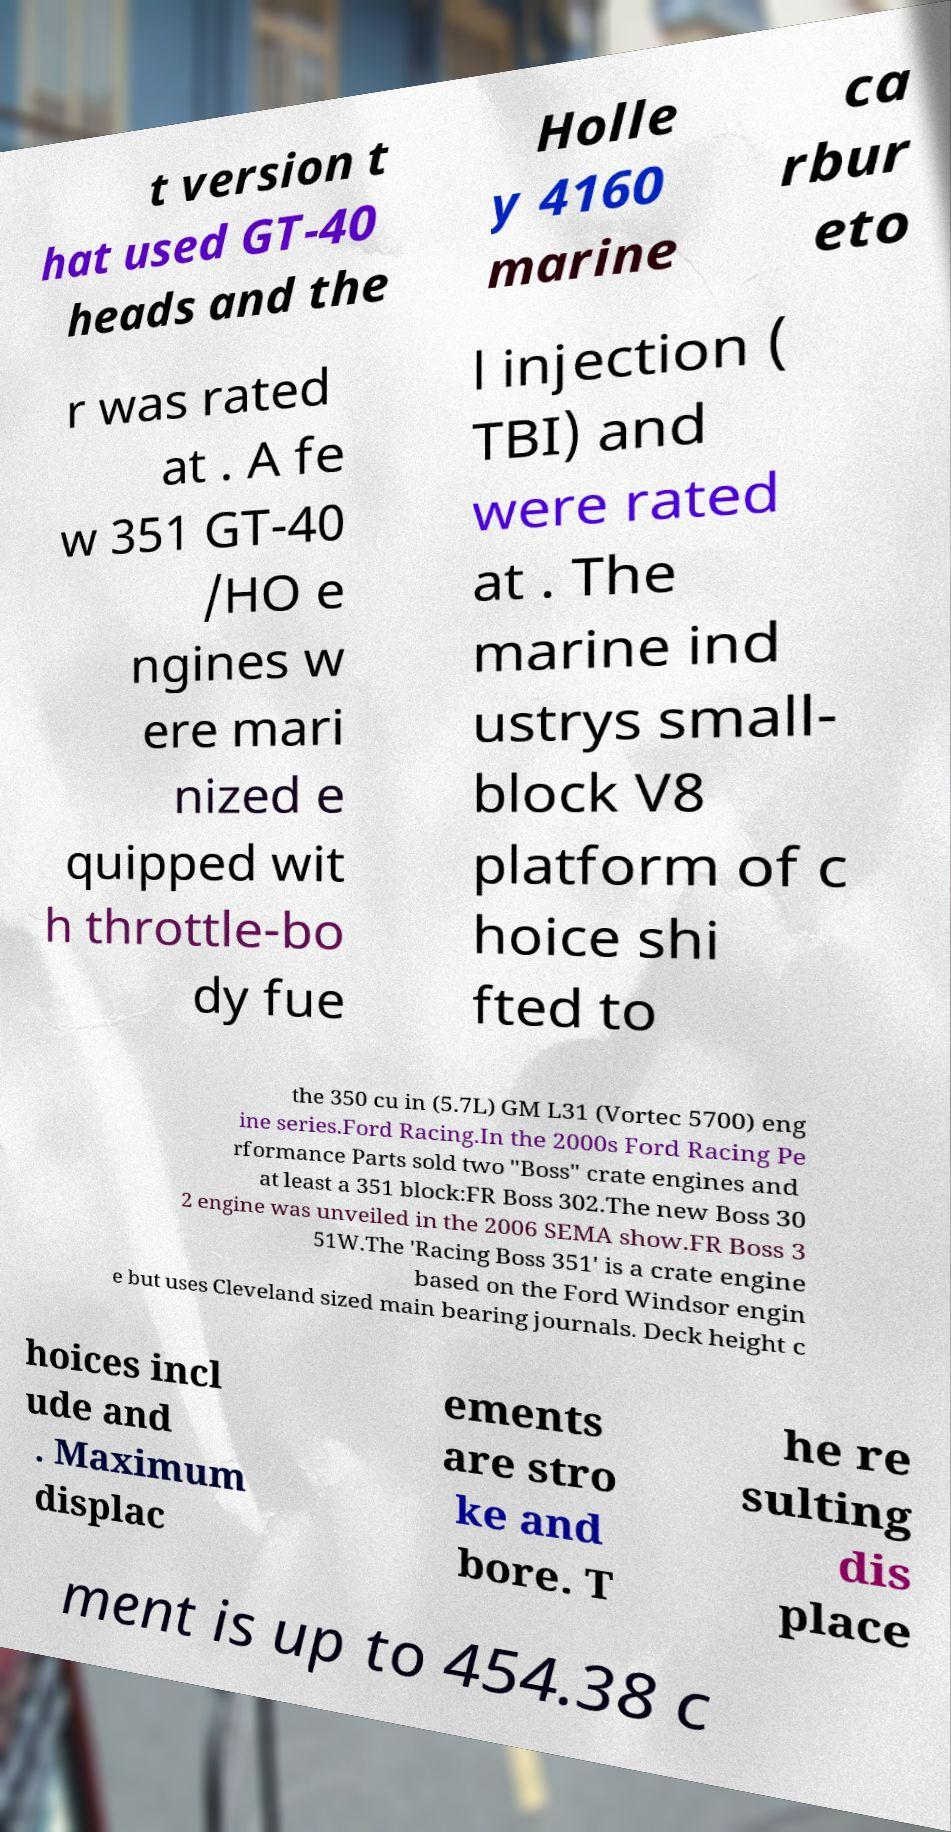For documentation purposes, I need the text within this image transcribed. Could you provide that? t version t hat used GT-40 heads and the Holle y 4160 marine ca rbur eto r was rated at . A fe w 351 GT-40 /HO e ngines w ere mari nized e quipped wit h throttle-bo dy fue l injection ( TBI) and were rated at . The marine ind ustrys small- block V8 platform of c hoice shi fted to the 350 cu in (5.7L) GM L31 (Vortec 5700) eng ine series.Ford Racing.In the 2000s Ford Racing Pe rformance Parts sold two "Boss" crate engines and at least a 351 block:FR Boss 302.The new Boss 30 2 engine was unveiled in the 2006 SEMA show.FR Boss 3 51W.The 'Racing Boss 351' is a crate engine based on the Ford Windsor engin e but uses Cleveland sized main bearing journals. Deck height c hoices incl ude and . Maximum displac ements are stro ke and bore. T he re sulting dis place ment is up to 454.38 c 